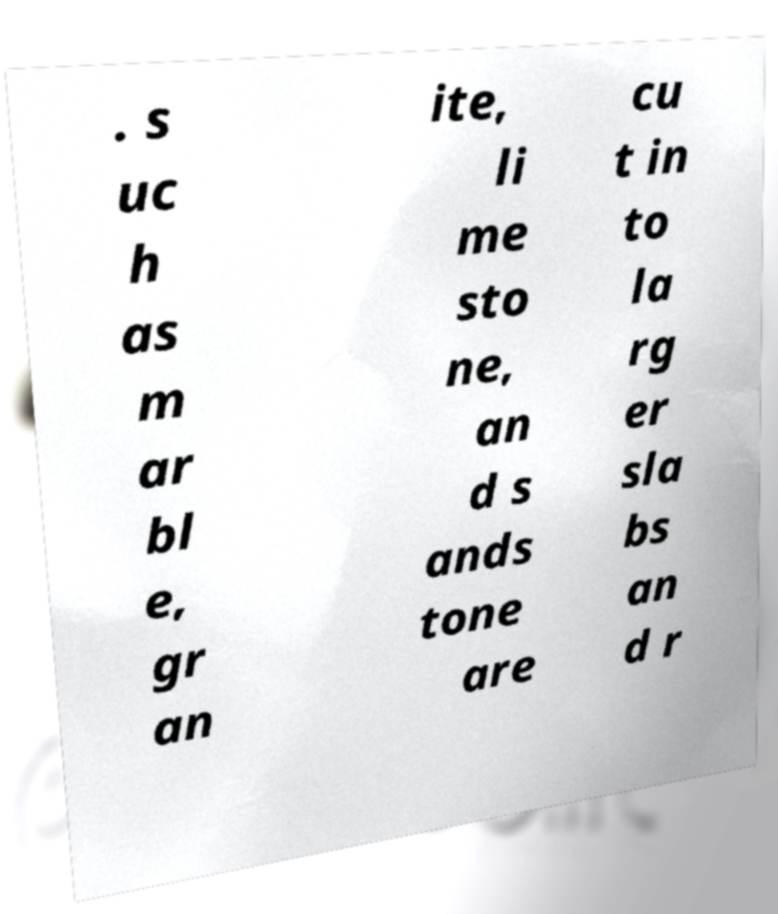Could you extract and type out the text from this image? . s uc h as m ar bl e, gr an ite, li me sto ne, an d s ands tone are cu t in to la rg er sla bs an d r 